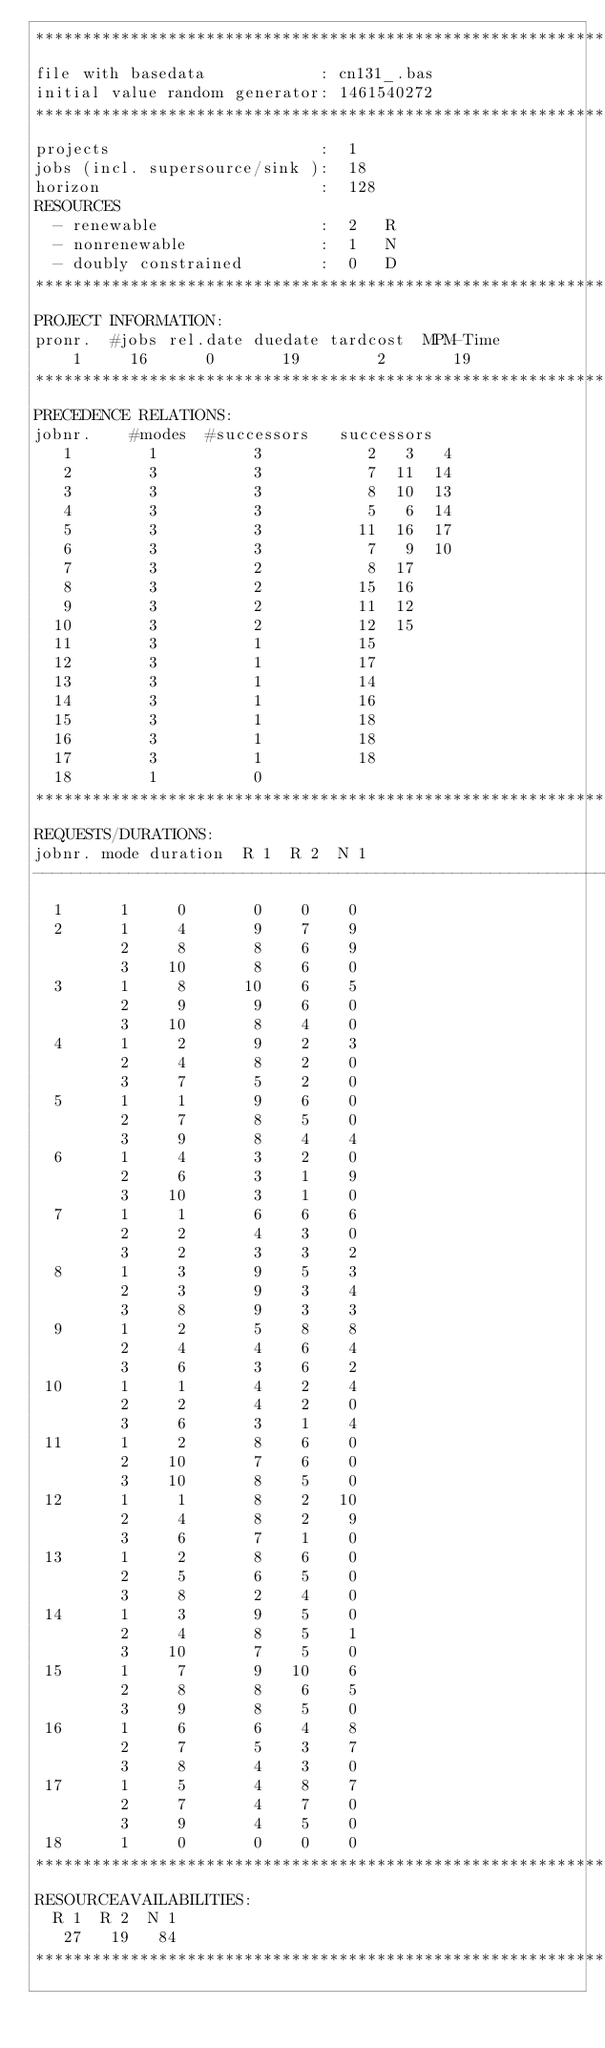Convert code to text. <code><loc_0><loc_0><loc_500><loc_500><_ObjectiveC_>************************************************************************
file with basedata            : cn131_.bas
initial value random generator: 1461540272
************************************************************************
projects                      :  1
jobs (incl. supersource/sink ):  18
horizon                       :  128
RESOURCES
  - renewable                 :  2   R
  - nonrenewable              :  1   N
  - doubly constrained        :  0   D
************************************************************************
PROJECT INFORMATION:
pronr.  #jobs rel.date duedate tardcost  MPM-Time
    1     16      0       19        2       19
************************************************************************
PRECEDENCE RELATIONS:
jobnr.    #modes  #successors   successors
   1        1          3           2   3   4
   2        3          3           7  11  14
   3        3          3           8  10  13
   4        3          3           5   6  14
   5        3          3          11  16  17
   6        3          3           7   9  10
   7        3          2           8  17
   8        3          2          15  16
   9        3          2          11  12
  10        3          2          12  15
  11        3          1          15
  12        3          1          17
  13        3          1          14
  14        3          1          16
  15        3          1          18
  16        3          1          18
  17        3          1          18
  18        1          0        
************************************************************************
REQUESTS/DURATIONS:
jobnr. mode duration  R 1  R 2  N 1
------------------------------------------------------------------------
  1      1     0       0    0    0
  2      1     4       9    7    9
         2     8       8    6    9
         3    10       8    6    0
  3      1     8      10    6    5
         2     9       9    6    0
         3    10       8    4    0
  4      1     2       9    2    3
         2     4       8    2    0
         3     7       5    2    0
  5      1     1       9    6    0
         2     7       8    5    0
         3     9       8    4    4
  6      1     4       3    2    0
         2     6       3    1    9
         3    10       3    1    0
  7      1     1       6    6    6
         2     2       4    3    0
         3     2       3    3    2
  8      1     3       9    5    3
         2     3       9    3    4
         3     8       9    3    3
  9      1     2       5    8    8
         2     4       4    6    4
         3     6       3    6    2
 10      1     1       4    2    4
         2     2       4    2    0
         3     6       3    1    4
 11      1     2       8    6    0
         2    10       7    6    0
         3    10       8    5    0
 12      1     1       8    2   10
         2     4       8    2    9
         3     6       7    1    0
 13      1     2       8    6    0
         2     5       6    5    0
         3     8       2    4    0
 14      1     3       9    5    0
         2     4       8    5    1
         3    10       7    5    0
 15      1     7       9   10    6
         2     8       8    6    5
         3     9       8    5    0
 16      1     6       6    4    8
         2     7       5    3    7
         3     8       4    3    0
 17      1     5       4    8    7
         2     7       4    7    0
         3     9       4    5    0
 18      1     0       0    0    0
************************************************************************
RESOURCEAVAILABILITIES:
  R 1  R 2  N 1
   27   19   84
************************************************************************
</code> 